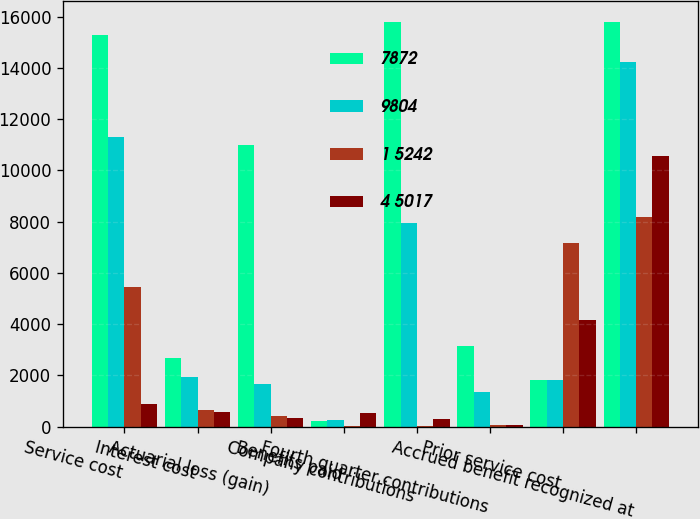Convert chart. <chart><loc_0><loc_0><loc_500><loc_500><stacked_bar_chart><ecel><fcel>Service cost<fcel>Interest cost<fcel>Actuarial loss (gain)<fcel>Benefits paid<fcel>Company contributions<fcel>Fourth quarter contributions<fcel>Prior service cost<fcel>Accrued benefit recognized at<nl><fcel>7872<fcel>15275<fcel>2693<fcel>10998<fcel>220<fcel>15784<fcel>3125<fcel>1800.5<fcel>15803<nl><fcel>9804<fcel>11290<fcel>1953<fcel>1648<fcel>253<fcel>7944<fcel>1355<fcel>1800.5<fcel>14232<nl><fcel>1 5242<fcel>5454<fcel>646<fcel>423<fcel>10<fcel>40<fcel>50<fcel>7159<fcel>8189<nl><fcel>4 5017<fcel>889<fcel>585<fcel>322<fcel>523<fcel>289<fcel>66<fcel>4175<fcel>10562<nl></chart> 